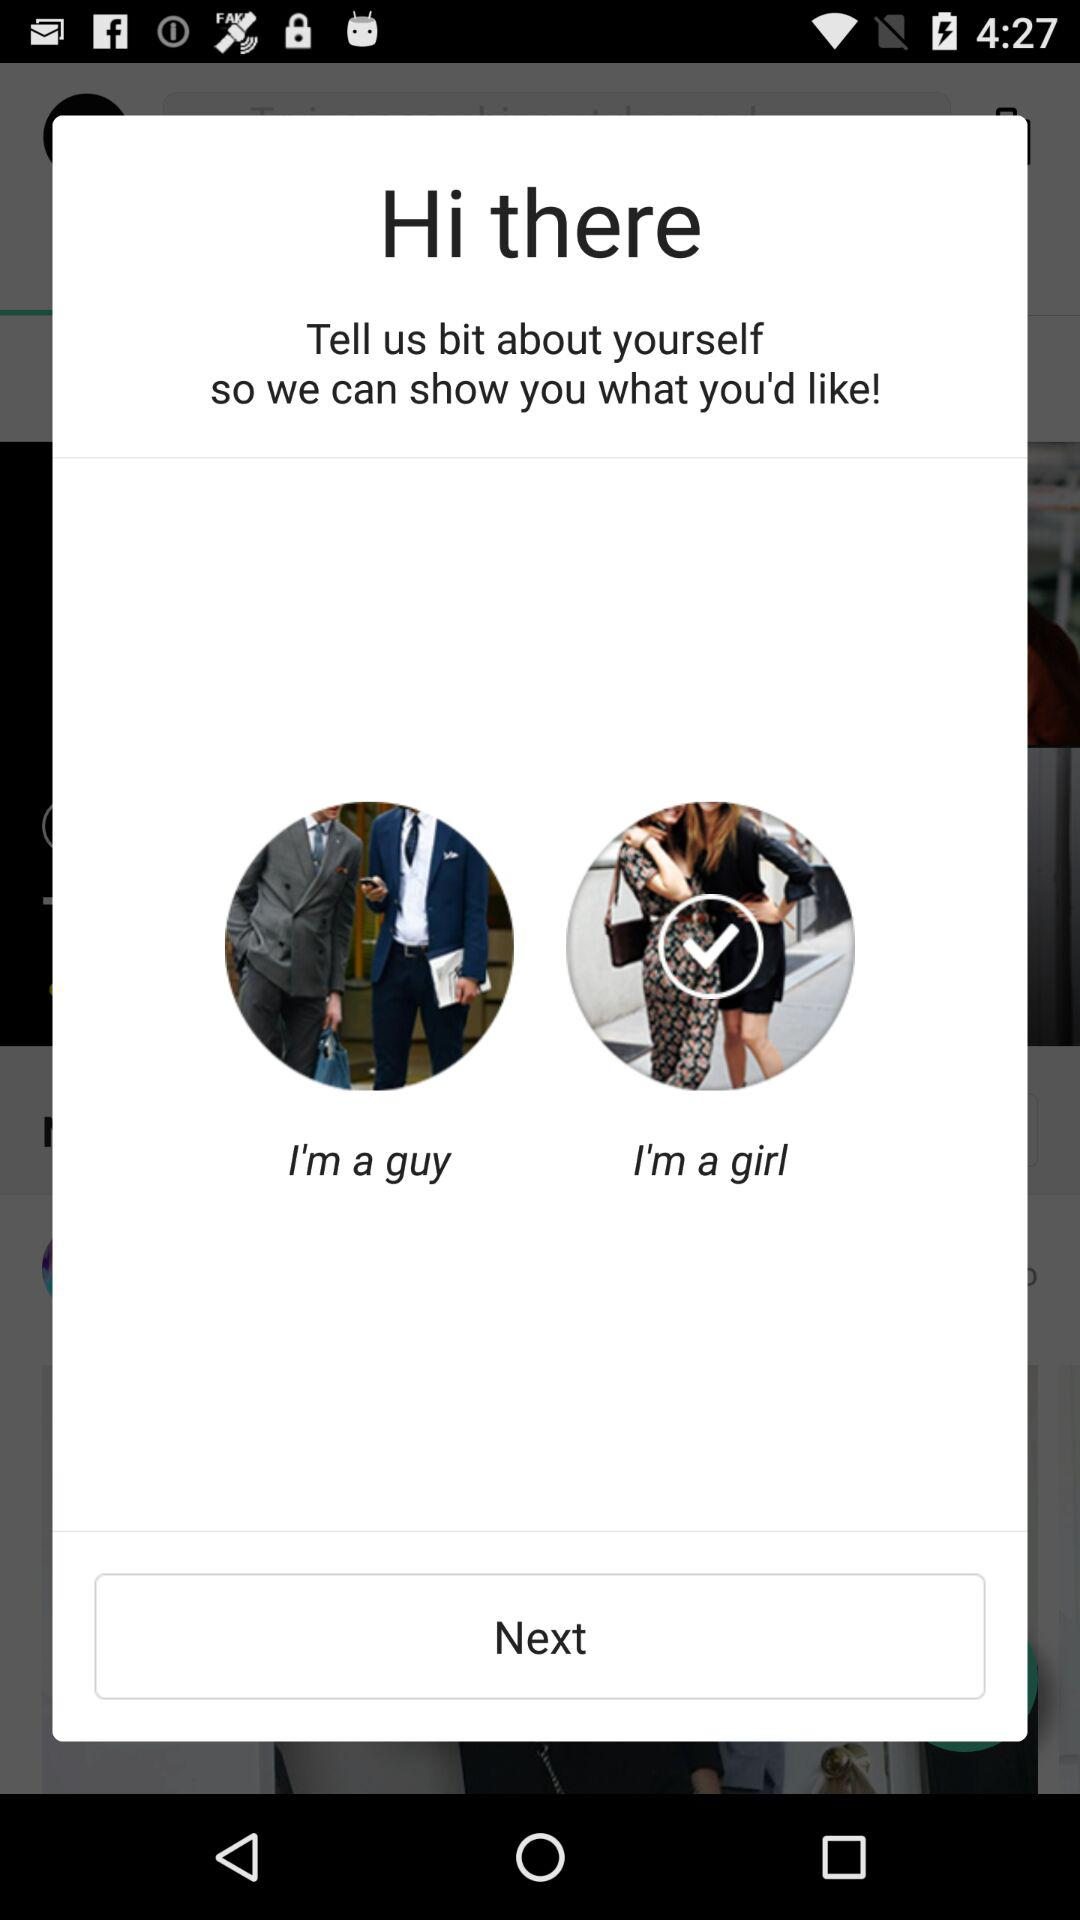Which option is selected? The selected option is "I'm a girl". 